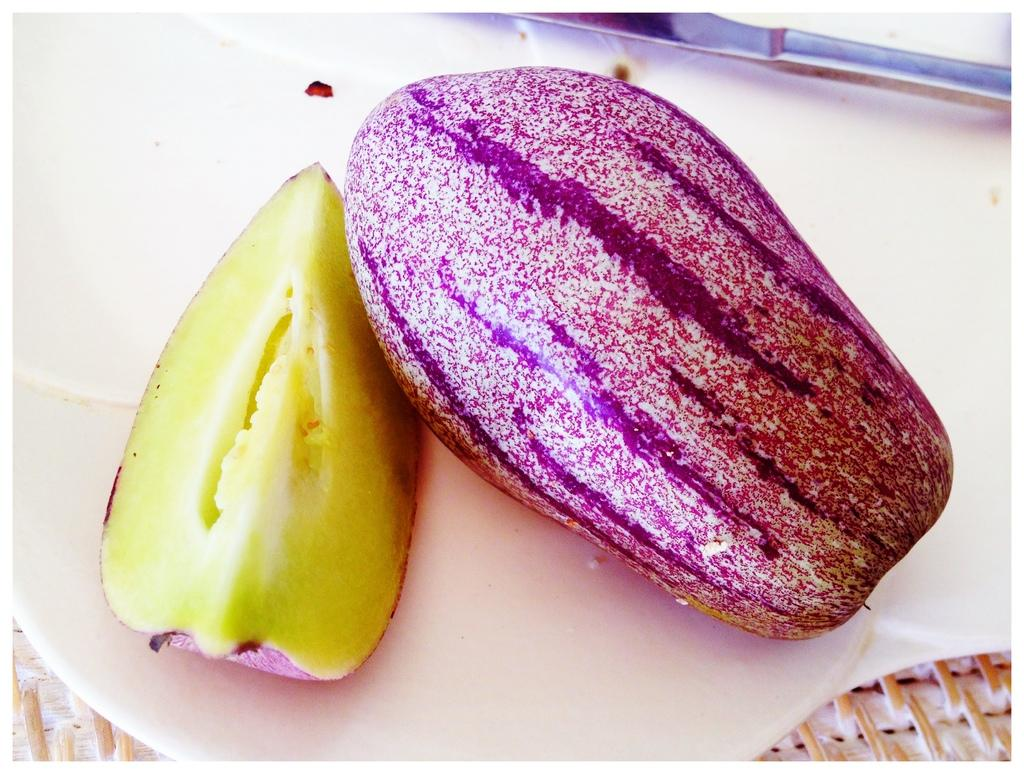What type of fruits are in the image? There are pepino fruits in the image. How are the pepino fruits arranged in the image? The pepino fruits are placed on a plate. What is the wrist doing in the image? There is no wrist present in the image; it only features pepino fruits placed on a plate. 